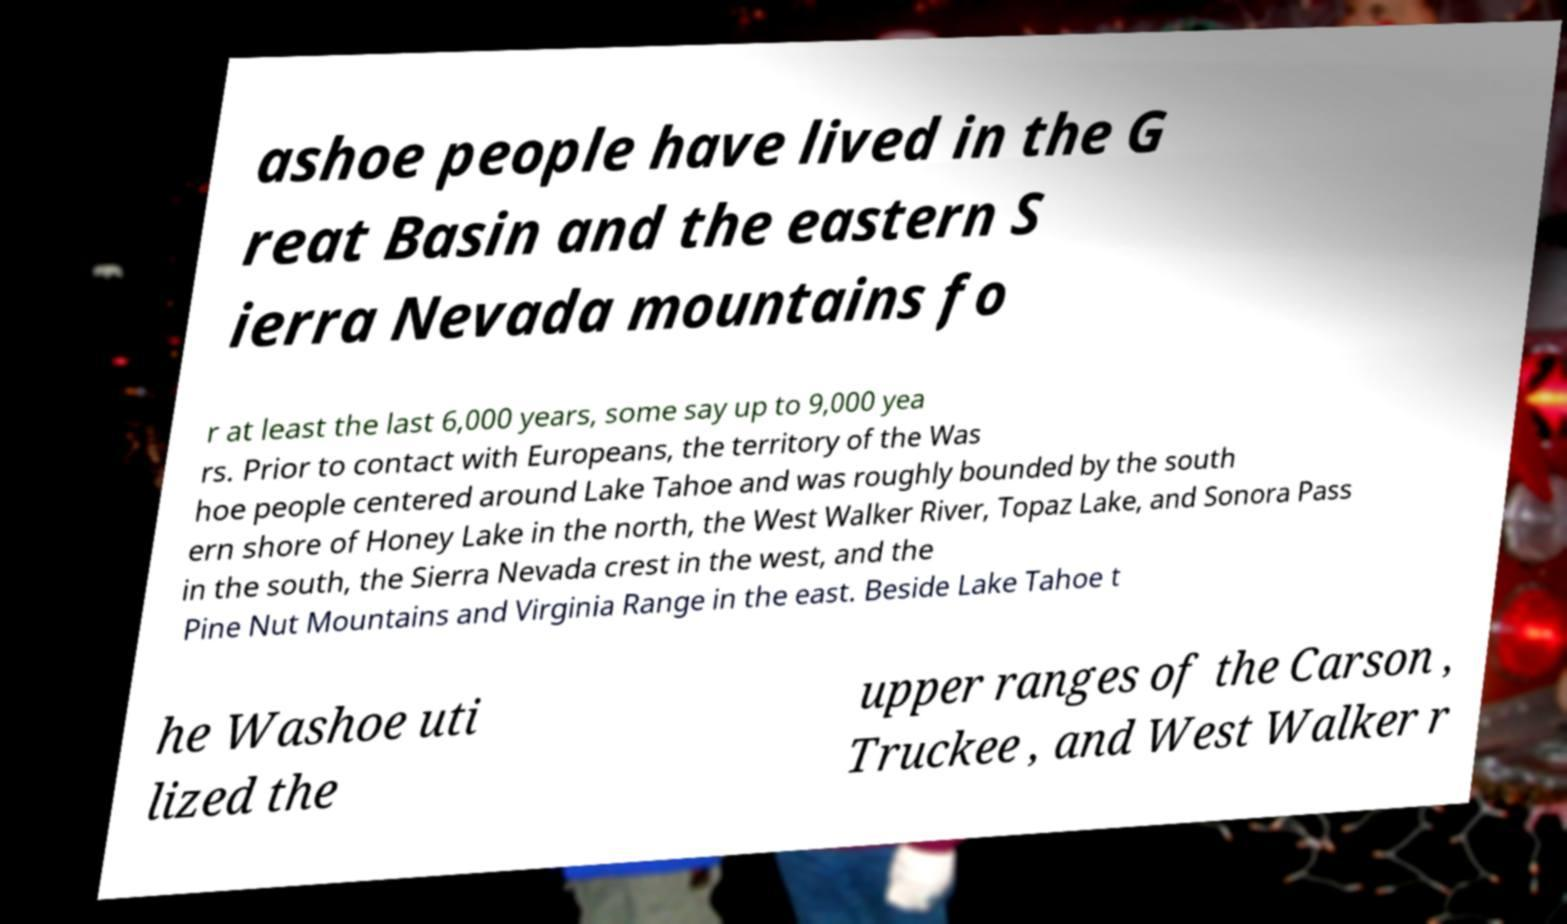Could you extract and type out the text from this image? ashoe people have lived in the G reat Basin and the eastern S ierra Nevada mountains fo r at least the last 6,000 years, some say up to 9,000 yea rs. Prior to contact with Europeans, the territory of the Was hoe people centered around Lake Tahoe and was roughly bounded by the south ern shore of Honey Lake in the north, the West Walker River, Topaz Lake, and Sonora Pass in the south, the Sierra Nevada crest in the west, and the Pine Nut Mountains and Virginia Range in the east. Beside Lake Tahoe t he Washoe uti lized the upper ranges of the Carson , Truckee , and West Walker r 